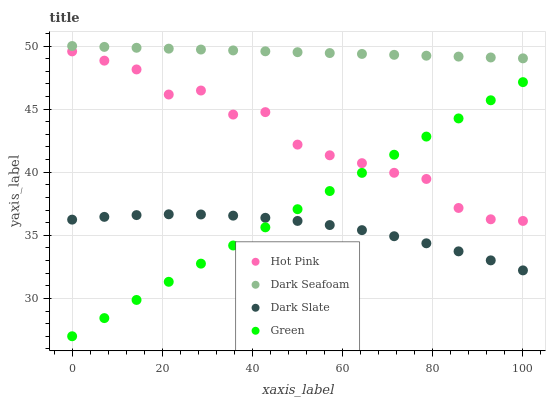Does Dark Slate have the minimum area under the curve?
Answer yes or no. Yes. Does Dark Seafoam have the maximum area under the curve?
Answer yes or no. Yes. Does Hot Pink have the minimum area under the curve?
Answer yes or no. No. Does Hot Pink have the maximum area under the curve?
Answer yes or no. No. Is Dark Seafoam the smoothest?
Answer yes or no. Yes. Is Hot Pink the roughest?
Answer yes or no. Yes. Is Hot Pink the smoothest?
Answer yes or no. No. Is Dark Seafoam the roughest?
Answer yes or no. No. Does Green have the lowest value?
Answer yes or no. Yes. Does Hot Pink have the lowest value?
Answer yes or no. No. Does Dark Seafoam have the highest value?
Answer yes or no. Yes. Does Hot Pink have the highest value?
Answer yes or no. No. Is Dark Slate less than Dark Seafoam?
Answer yes or no. Yes. Is Dark Seafoam greater than Hot Pink?
Answer yes or no. Yes. Does Hot Pink intersect Green?
Answer yes or no. Yes. Is Hot Pink less than Green?
Answer yes or no. No. Is Hot Pink greater than Green?
Answer yes or no. No. Does Dark Slate intersect Dark Seafoam?
Answer yes or no. No. 